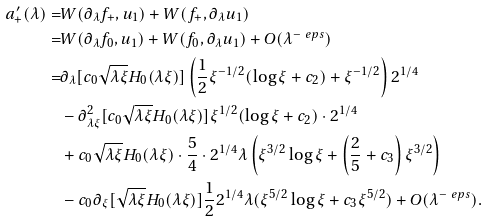<formula> <loc_0><loc_0><loc_500><loc_500>a ^ { \prime } _ { + } ( \lambda ) = & W ( \partial _ { \lambda } f _ { + } , u _ { 1 } ) + W ( f _ { + } , \partial _ { \lambda } u _ { 1 } ) \\ = & W ( \partial _ { \lambda } f _ { 0 } , u _ { 1 } ) + W ( f _ { 0 } , \partial _ { \lambda } u _ { 1 } ) + O ( \lambda ^ { - \ e p s } ) \\ = & \partial _ { \lambda } [ c _ { 0 } \sqrt { \lambda \xi } H _ { 0 } ( \lambda \xi ) ] \left ( \frac { 1 } { 2 } \xi ^ { - 1 / 2 } ( \log \xi + c _ { 2 } ) + \xi ^ { - 1 / 2 } \right ) 2 ^ { 1 / 4 } \\ & - \partial ^ { 2 } _ { \lambda \xi } [ c _ { 0 } \sqrt { \lambda \xi } H _ { 0 } ( \lambda \xi ) ] \xi ^ { 1 / 2 } ( \log \xi + c _ { 2 } ) \cdot 2 ^ { 1 / 4 } \\ & + c _ { 0 } \sqrt { \lambda \xi } H _ { 0 } ( \lambda \xi ) \cdot \frac { 5 } { 4 } \cdot 2 ^ { 1 / 4 } \lambda \left ( \xi ^ { 3 / 2 } \log \xi + \left ( \frac { 2 } { 5 } + c _ { 3 } \right ) \xi ^ { 3 / 2 } \right ) \\ & - c _ { 0 } \partial _ { \xi } [ \sqrt { \lambda \xi } H _ { 0 } ( \lambda \xi ) ] \frac { 1 } { 2 } 2 ^ { 1 / 4 } \lambda ( \xi ^ { 5 / 2 } \log \xi + c _ { 3 } \xi ^ { 5 / 2 } ) + O ( \lambda ^ { - \ e p s } ) .</formula> 